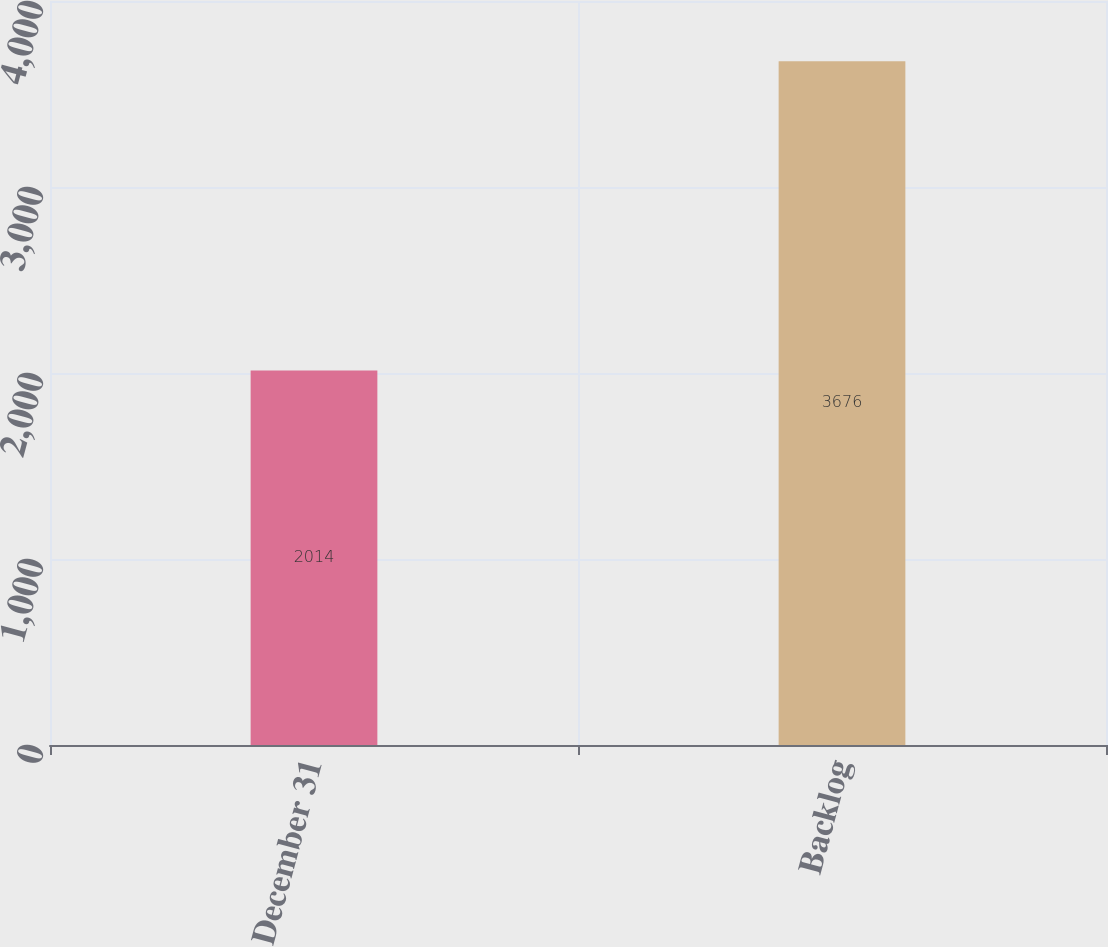Convert chart to OTSL. <chart><loc_0><loc_0><loc_500><loc_500><bar_chart><fcel>December 31<fcel>Backlog<nl><fcel>2014<fcel>3676<nl></chart> 